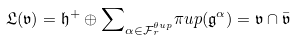<formula> <loc_0><loc_0><loc_500><loc_500>\mathfrak { L } ( \mathfrak { v } ) = \mathfrak { h } ^ { + } \oplus { \sum } _ { \alpha \in \mathcal { F } ^ { \theta u p } _ { r } } \pi u p ( \mathfrak { g } ^ { \alpha } ) = \mathfrak { v } \cap \bar { \mathfrak { v } }</formula> 